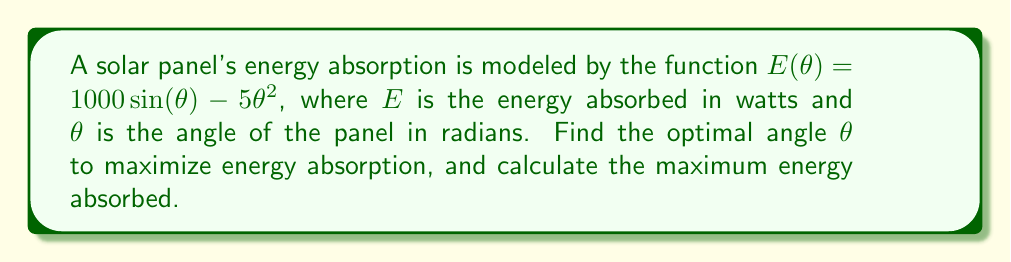Can you answer this question? To find the optimal angle for maximum energy absorption, we need to find the maximum of the function $E(\theta)$. This can be done by following these steps:

1) First, we need to find the derivative of $E(\theta)$:

   $$\frac{dE}{d\theta} = 1000 \cos(\theta) - 10\theta$$

2) To find the maximum, we set the derivative equal to zero and solve for $\theta$:

   $$1000 \cos(\theta) - 10\theta = 0$$

3) This equation cannot be solved algebraically. We need to use numerical methods or a graphing calculator to find the solution. The solution is approximately:

   $$\theta \approx 1.287 \text{ radians}$$

4) To confirm this is a maximum (not a minimum), we can check the second derivative:

   $$\frac{d^2E}{d\theta^2} = -1000 \sin(\theta) - 10$$

   At $\theta = 1.287$, this is negative, confirming a maximum.

5) To find the maximum energy absorbed, we substitute this value back into the original function:

   $$E(1.287) = 1000 \sin(1.287) - 5(1.287)^2 \approx 915.39 \text{ watts}$$

Thus, the optimal angle is approximately 1.287 radians (or about 73.7 degrees), and the maximum energy absorbed is approximately 915.39 watts.
Answer: $\theta \approx 1.287 \text{ radians}$, $E_{max} \approx 915.39 \text{ watts}$ 